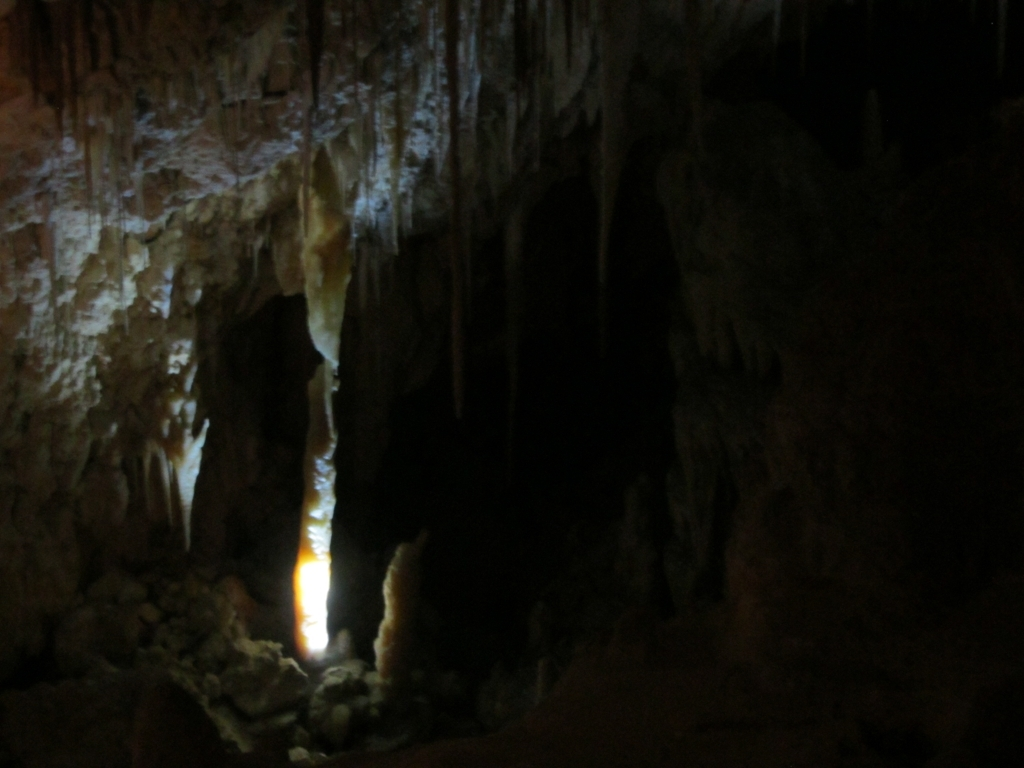What is the main issue with the lighting in this image?
A. Perfect lighting
B. Insufficient lighting
C. Excessive lighting
D. Natural lighting
Answer with the option's letter from the given choices directly.
 B. 